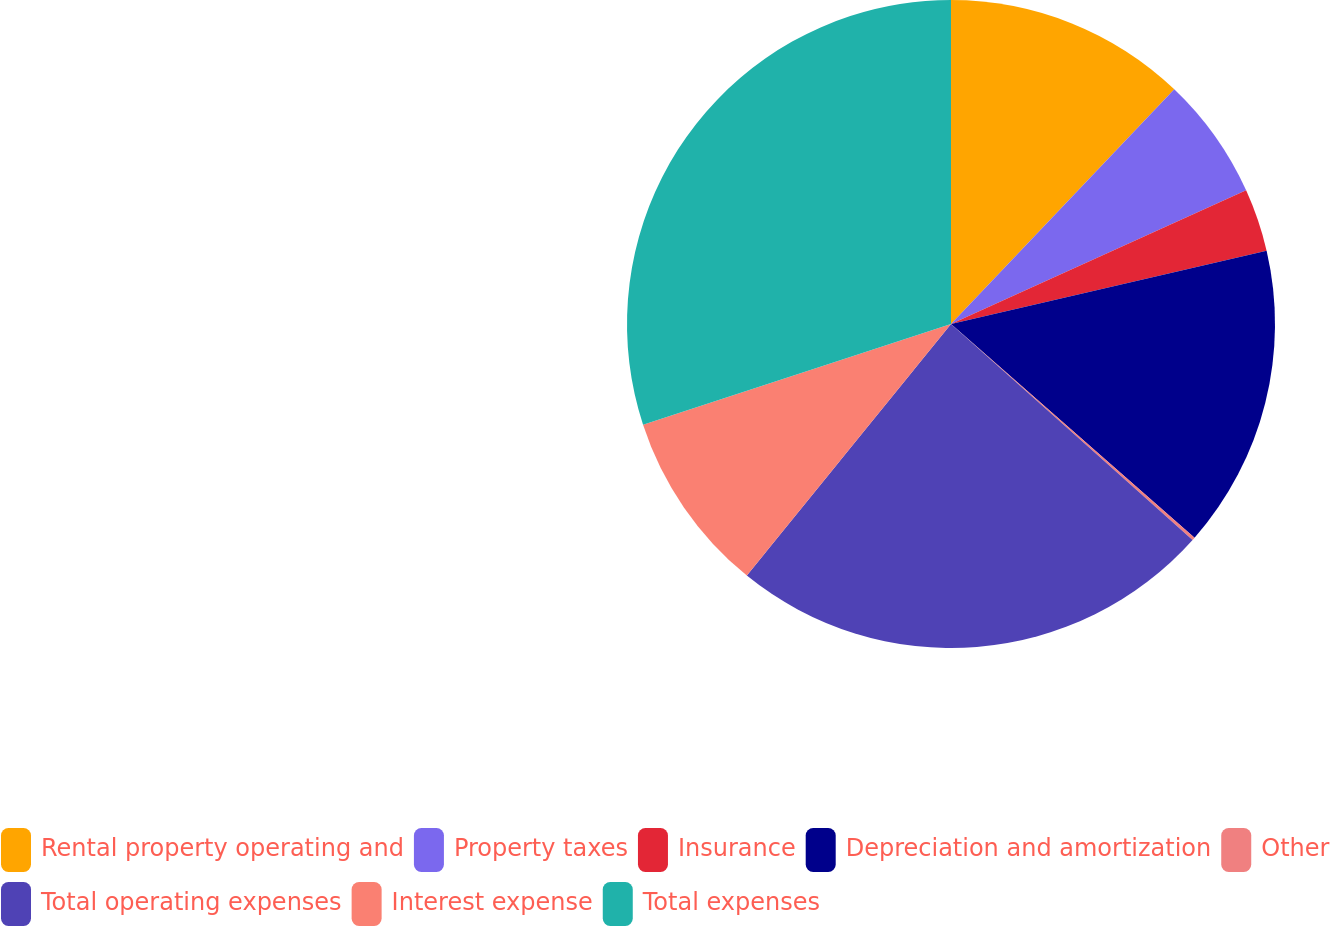<chart> <loc_0><loc_0><loc_500><loc_500><pie_chart><fcel>Rental property operating and<fcel>Property taxes<fcel>Insurance<fcel>Depreciation and amortization<fcel>Other<fcel>Total operating expenses<fcel>Interest expense<fcel>Total expenses<nl><fcel>12.1%<fcel>6.13%<fcel>3.14%<fcel>15.09%<fcel>0.15%<fcel>24.24%<fcel>9.12%<fcel>30.03%<nl></chart> 